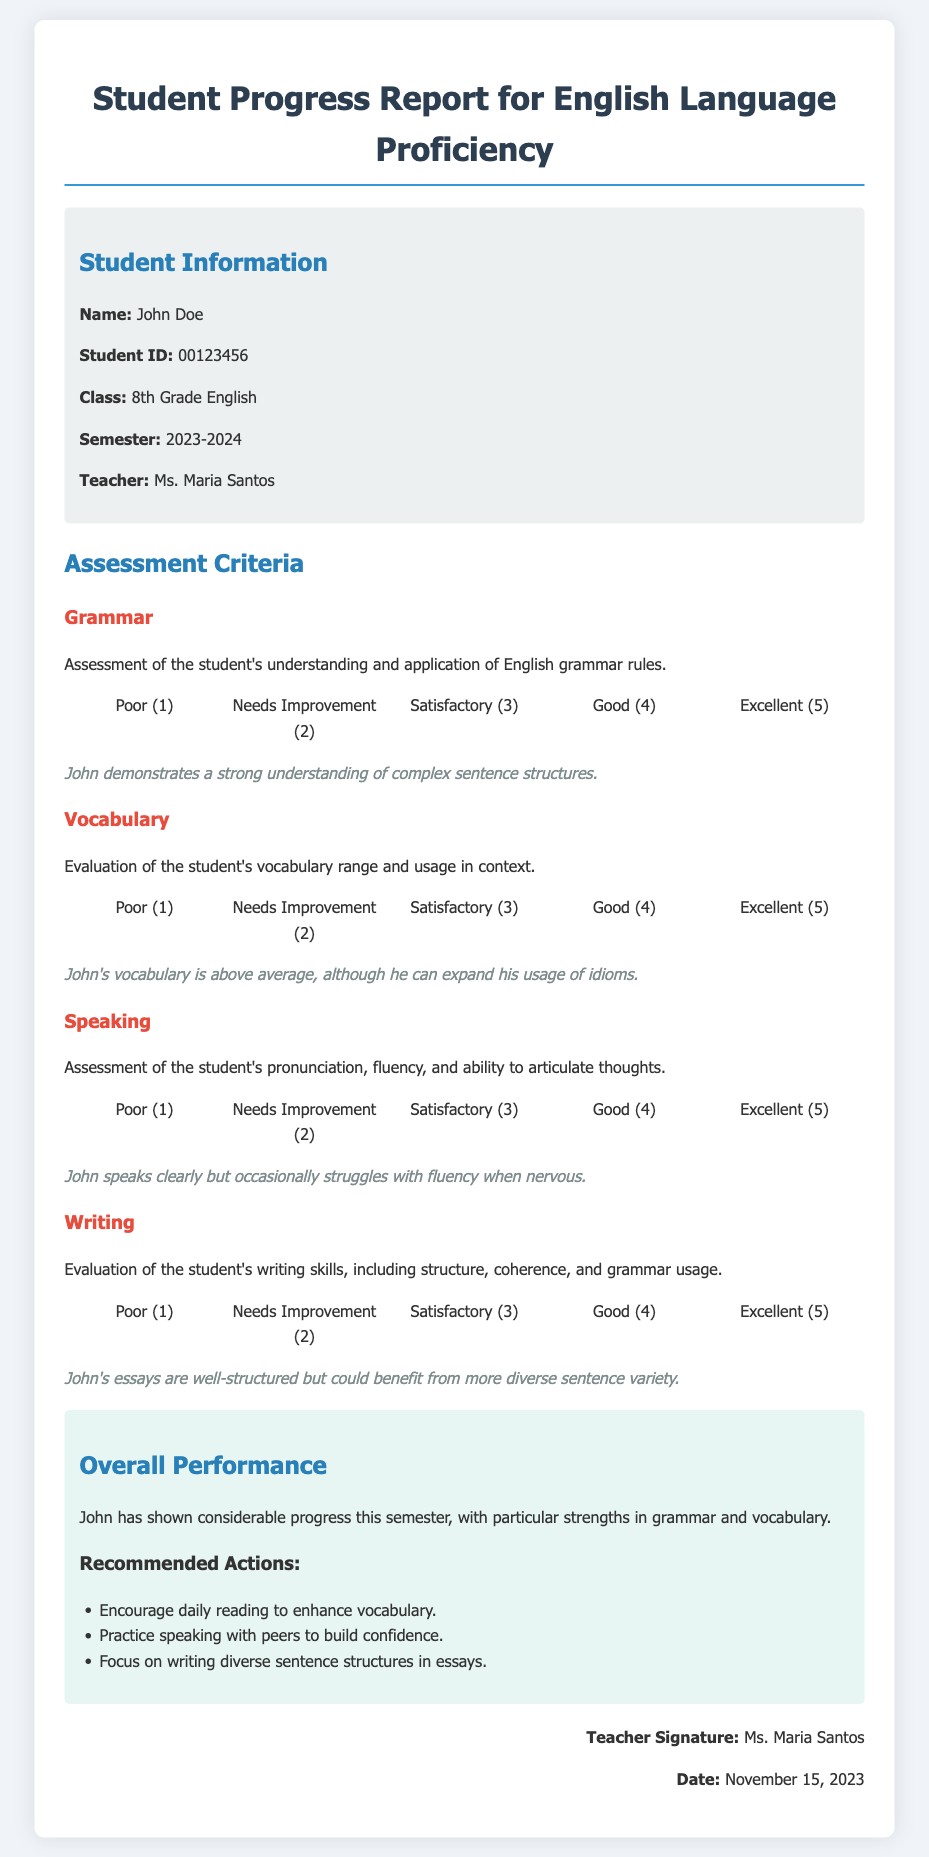What is the name of the student? The document provides specific information about the student, including their name, which is mentioned at the beginning of the report.
Answer: John Doe What is the student ID? The report contains the student's ID listed in the student information section.
Answer: 00123456 What grade is the student in? The document specifies the student's grade in the same section where other personal information is presented.
Answer: 8th Grade English What is the semester for this report? The semester is clearly stated in the student information section, indicating the time period for the assessment.
Answer: 2023-2024 Who is the teacher? The teacher's name is noted in the student information section, identifying who prepared the report.
Answer: Ms. Maria Santos What are John's strengths based on the assessment? The overall performance section summarizes John's strengths in specific areas based on the evaluations.
Answer: Grammar and vocabulary What is the rating scale for vocabulary? The rating scale is provided for each assessment criteria, and it includes the specific labels used to assess vocabulary.
Answer: Poor (1), Needs Improvement (2), Satisfactory (3), Good (4), Excellent (5) What is one recommended action for John? The report includes recommended actions for further improvement, which can be identified in the overall performance section.
Answer: Encourage daily reading to enhance vocabulary Why does John struggle with speaking? The assessment includes a comment regarding John's speaking skills and highlights a specific challenge he faces.
Answer: Occasionally struggles with fluency when nervous What is the date of the report? The date appears at the end of the document, indicating when this progress report was prepared.
Answer: November 15, 2023 